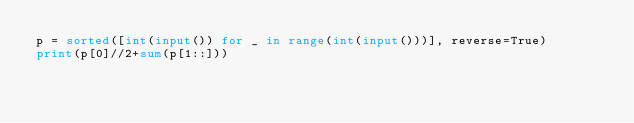<code> <loc_0><loc_0><loc_500><loc_500><_Python_>p = sorted([int(input()) for _ in range(int(input()))], reverse=True)
print(p[0]//2+sum(p[1::]))</code> 